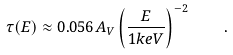<formula> <loc_0><loc_0><loc_500><loc_500>\tau ( E ) \approx 0 . 0 5 6 A _ { V } \left ( \frac { E } { 1 k e V } \right ) ^ { - 2 } \quad .</formula> 